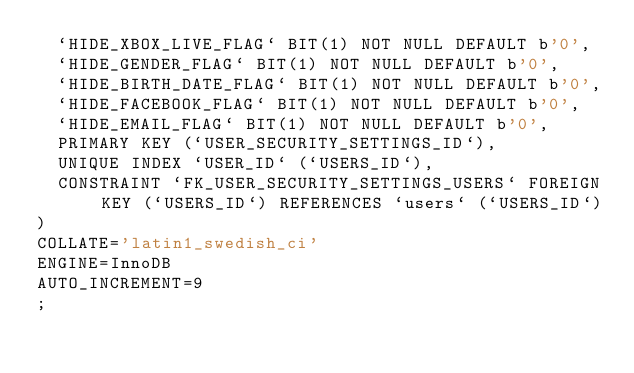<code> <loc_0><loc_0><loc_500><loc_500><_SQL_>	`HIDE_XBOX_LIVE_FLAG` BIT(1) NOT NULL DEFAULT b'0',
	`HIDE_GENDER_FLAG` BIT(1) NOT NULL DEFAULT b'0',
	`HIDE_BIRTH_DATE_FLAG` BIT(1) NOT NULL DEFAULT b'0',
	`HIDE_FACEBOOK_FLAG` BIT(1) NOT NULL DEFAULT b'0',
	`HIDE_EMAIL_FLAG` BIT(1) NOT NULL DEFAULT b'0',
	PRIMARY KEY (`USER_SECURITY_SETTINGS_ID`),
	UNIQUE INDEX `USER_ID` (`USERS_ID`),
	CONSTRAINT `FK_USER_SECURITY_SETTINGS_USERS` FOREIGN KEY (`USERS_ID`) REFERENCES `users` (`USERS_ID`)
)
COLLATE='latin1_swedish_ci'
ENGINE=InnoDB
AUTO_INCREMENT=9
;
</code> 